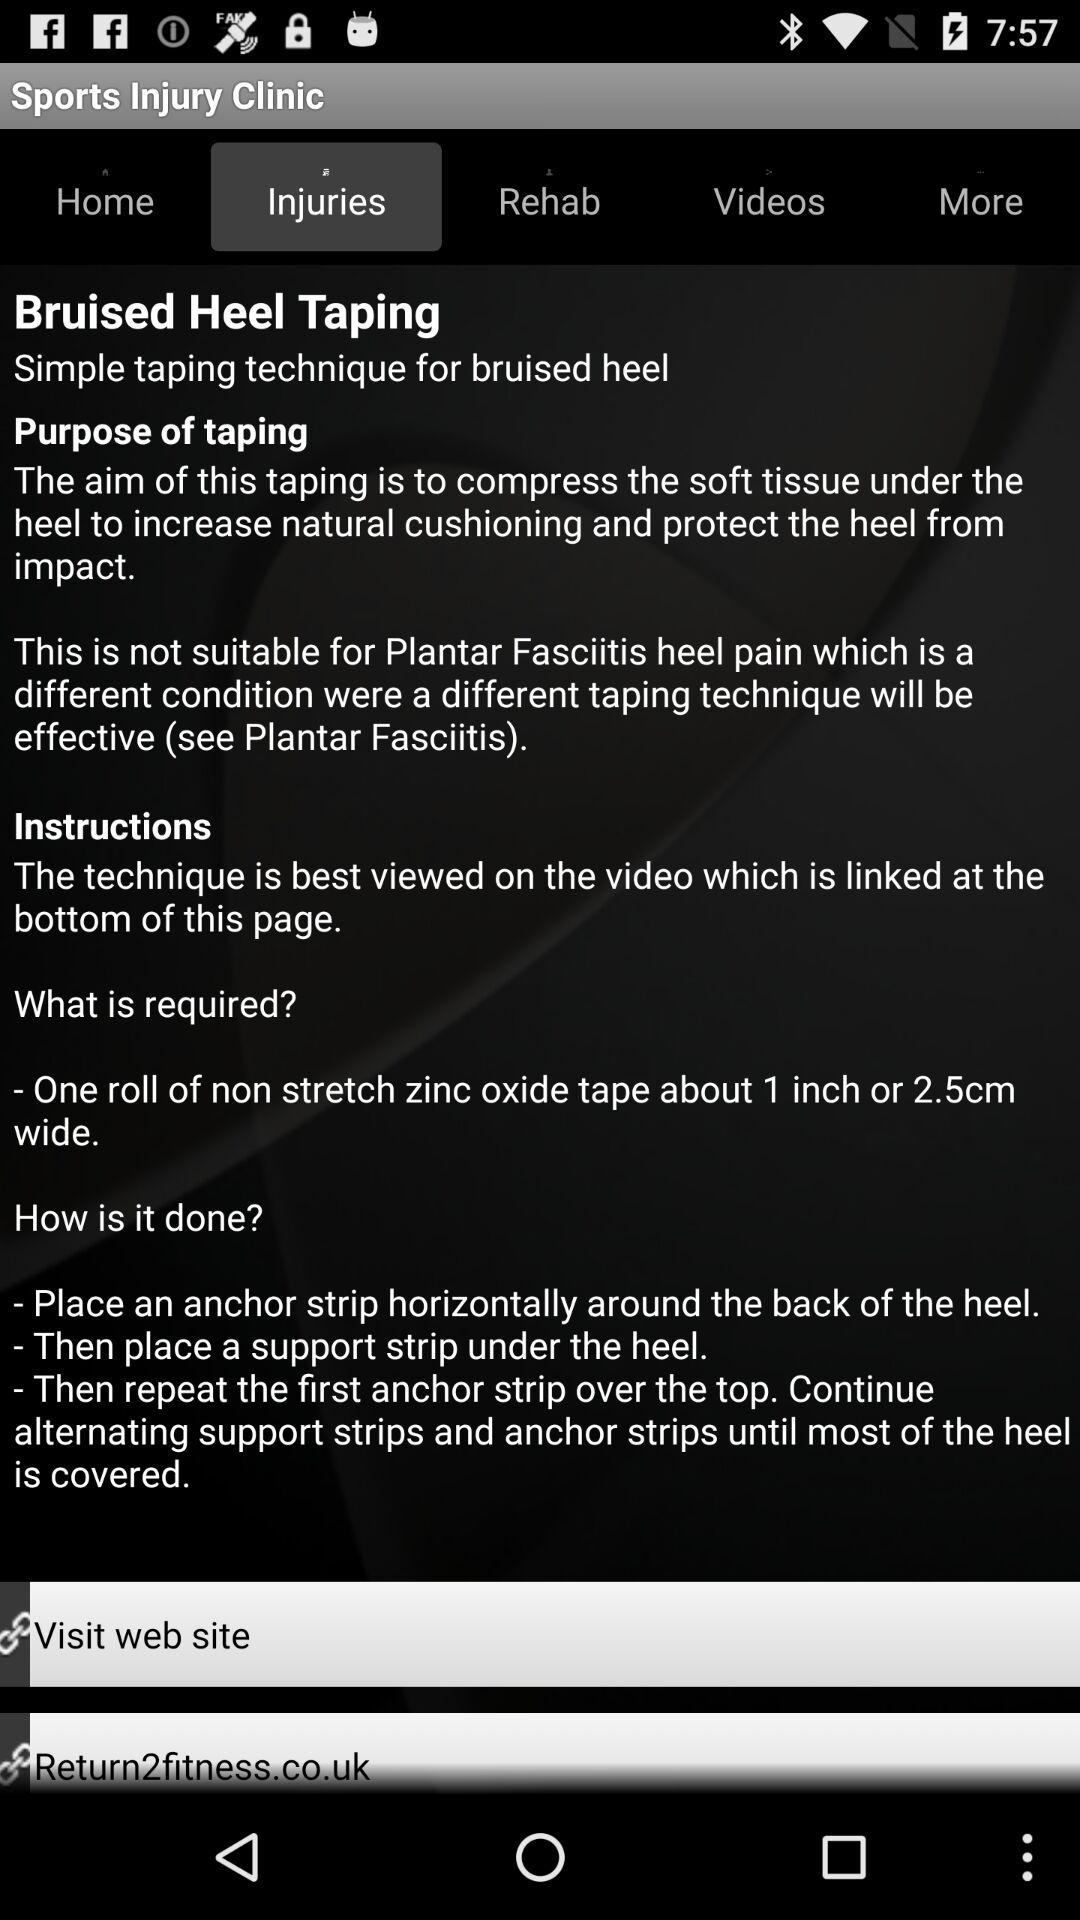What is the purpose of taping? The purpose of taping is "The aim of this taping is to compress the soft tissue under the heel to increase natural cushioning and protect the heel from impact. This is not suitable for Plantar Fasciitis heel pain which is a different condition were a different taping technique will be effective (see Plantar Fasciitis)". 